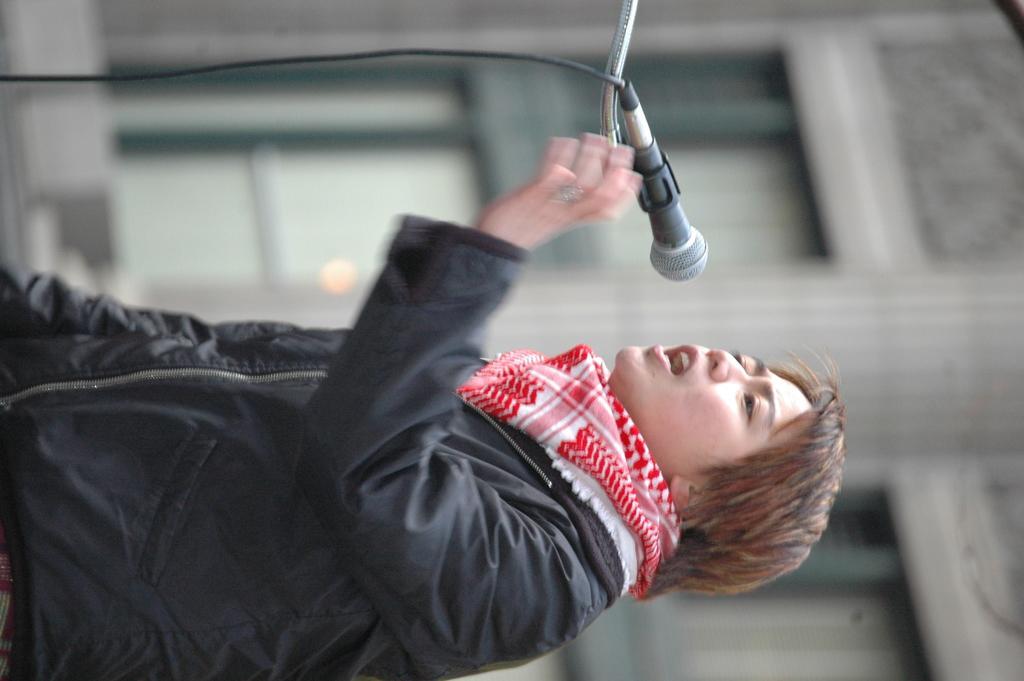Describe this image in one or two sentences. It is a tilted picture,there is a person standing and talking something,there is a mic in front of the person and the background is blurry. 